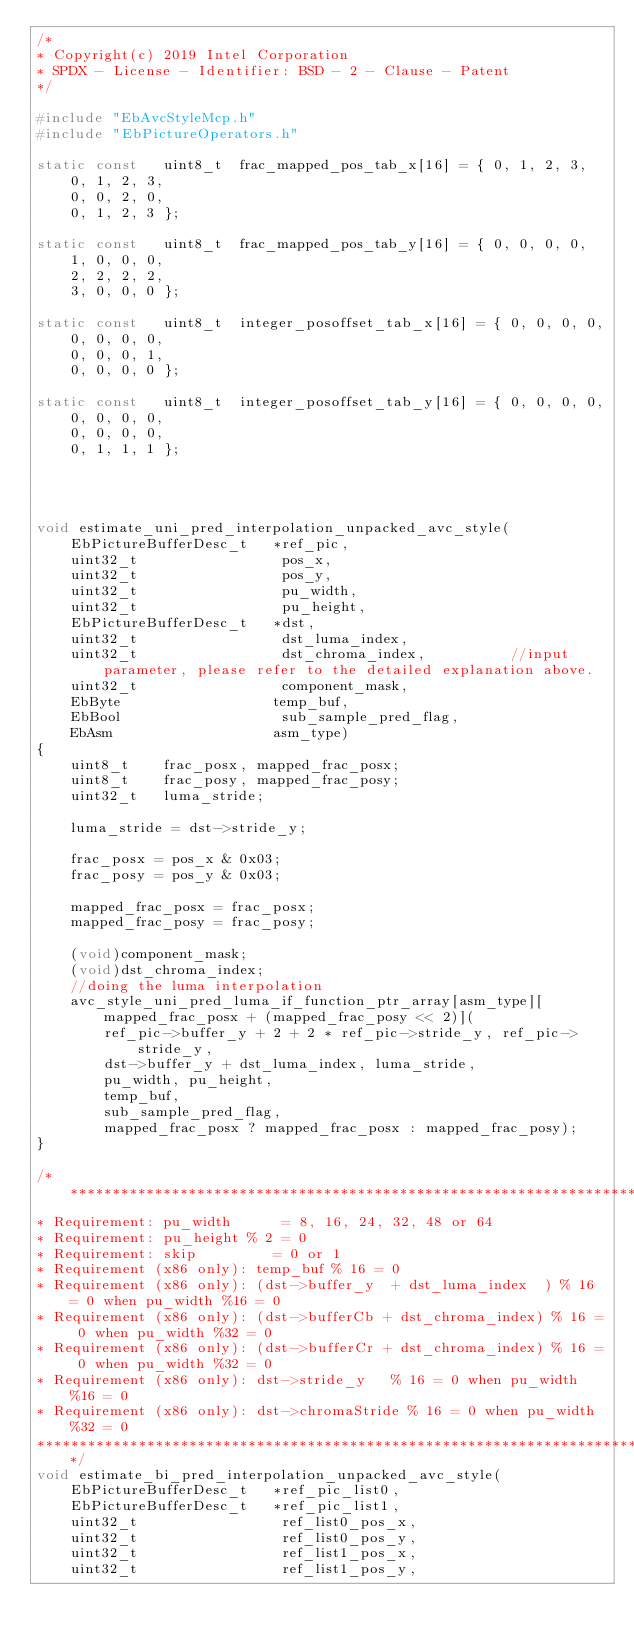<code> <loc_0><loc_0><loc_500><loc_500><_C_>/*
* Copyright(c) 2019 Intel Corporation
* SPDX - License - Identifier: BSD - 2 - Clause - Patent
*/

#include "EbAvcStyleMcp.h"
#include "EbPictureOperators.h"

static const   uint8_t  frac_mapped_pos_tab_x[16] = { 0, 1, 2, 3,
    0, 1, 2, 3,
    0, 0, 2, 0,
    0, 1, 2, 3 };

static const   uint8_t  frac_mapped_pos_tab_y[16] = { 0, 0, 0, 0,
    1, 0, 0, 0,
    2, 2, 2, 2,
    3, 0, 0, 0 };

static const   uint8_t  integer_posoffset_tab_x[16] = { 0, 0, 0, 0,
    0, 0, 0, 0,
    0, 0, 0, 1,
    0, 0, 0, 0 };

static const   uint8_t  integer_posoffset_tab_y[16] = { 0, 0, 0, 0,
    0, 0, 0, 0,
    0, 0, 0, 0,
    0, 1, 1, 1 };




void estimate_uni_pred_interpolation_unpacked_avc_style(
    EbPictureBufferDesc_t   *ref_pic,
    uint32_t                 pos_x,
    uint32_t                 pos_y,
    uint32_t                 pu_width,
    uint32_t                 pu_height,
    EbPictureBufferDesc_t   *dst,
    uint32_t                 dst_luma_index,
    uint32_t                 dst_chroma_index,          //input parameter, please refer to the detailed explanation above.
    uint32_t                 component_mask,
    EbByte                  temp_buf,
    EbBool                   sub_sample_pred_flag,
    EbAsm                   asm_type)
{
    uint8_t    frac_posx, mapped_frac_posx;
    uint8_t    frac_posy, mapped_frac_posy;
    uint32_t   luma_stride;

    luma_stride = dst->stride_y;

    frac_posx = pos_x & 0x03;
    frac_posy = pos_y & 0x03;

    mapped_frac_posx = frac_posx;
    mapped_frac_posy = frac_posy;

    (void)component_mask;
    (void)dst_chroma_index;
    //doing the luma interpolation
    avc_style_uni_pred_luma_if_function_ptr_array[asm_type][mapped_frac_posx + (mapped_frac_posy << 2)](
        ref_pic->buffer_y + 2 + 2 * ref_pic->stride_y, ref_pic->stride_y,
        dst->buffer_y + dst_luma_index, luma_stride,
        pu_width, pu_height,
        temp_buf,
        sub_sample_pred_flag,
        mapped_frac_posx ? mapped_frac_posx : mapped_frac_posy);
}

/*******************************************************************************
* Requirement: pu_width      = 8, 16, 24, 32, 48 or 64
* Requirement: pu_height % 2 = 0
* Requirement: skip         = 0 or 1
* Requirement (x86 only): temp_buf % 16 = 0
* Requirement (x86 only): (dst->buffer_y  + dst_luma_index  ) % 16 = 0 when pu_width %16 = 0
* Requirement (x86 only): (dst->bufferCb + dst_chroma_index) % 16 = 0 when pu_width %32 = 0
* Requirement (x86 only): (dst->bufferCr + dst_chroma_index) % 16 = 0 when pu_width %32 = 0
* Requirement (x86 only): dst->stride_y   % 16 = 0 when pu_width %16 = 0
* Requirement (x86 only): dst->chromaStride % 16 = 0 when pu_width %32 = 0
*******************************************************************************/
void estimate_bi_pred_interpolation_unpacked_avc_style(
    EbPictureBufferDesc_t   *ref_pic_list0,
    EbPictureBufferDesc_t   *ref_pic_list1,
    uint32_t                 ref_list0_pos_x,
    uint32_t                 ref_list0_pos_y,
    uint32_t                 ref_list1_pos_x,
    uint32_t                 ref_list1_pos_y,</code> 